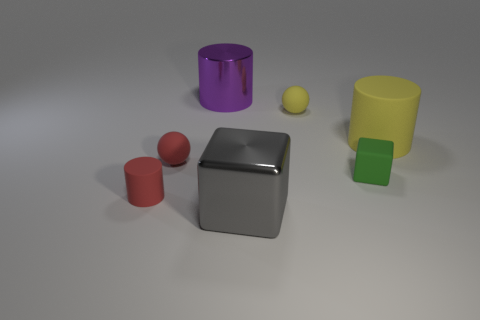Is the number of matte cylinders behind the large yellow cylinder the same as the number of spheres?
Offer a terse response. No. What is the color of the tiny matte cylinder?
Your answer should be very brief. Red. There is a red object that is made of the same material as the red cylinder; what size is it?
Your response must be concise. Small. What is the color of the large cylinder that is the same material as the small cube?
Keep it short and to the point. Yellow. Are there any yellow cylinders that have the same size as the shiny block?
Your answer should be very brief. Yes. What material is the green thing that is the same shape as the gray object?
Your response must be concise. Rubber. The yellow rubber object that is the same size as the green block is what shape?
Ensure brevity in your answer.  Sphere. Is there a big purple shiny object of the same shape as the tiny yellow matte object?
Ensure brevity in your answer.  No. The large thing behind the tiny ball behind the large matte thing is what shape?
Make the answer very short. Cylinder. What is the shape of the large gray metal thing?
Your answer should be very brief. Cube. 